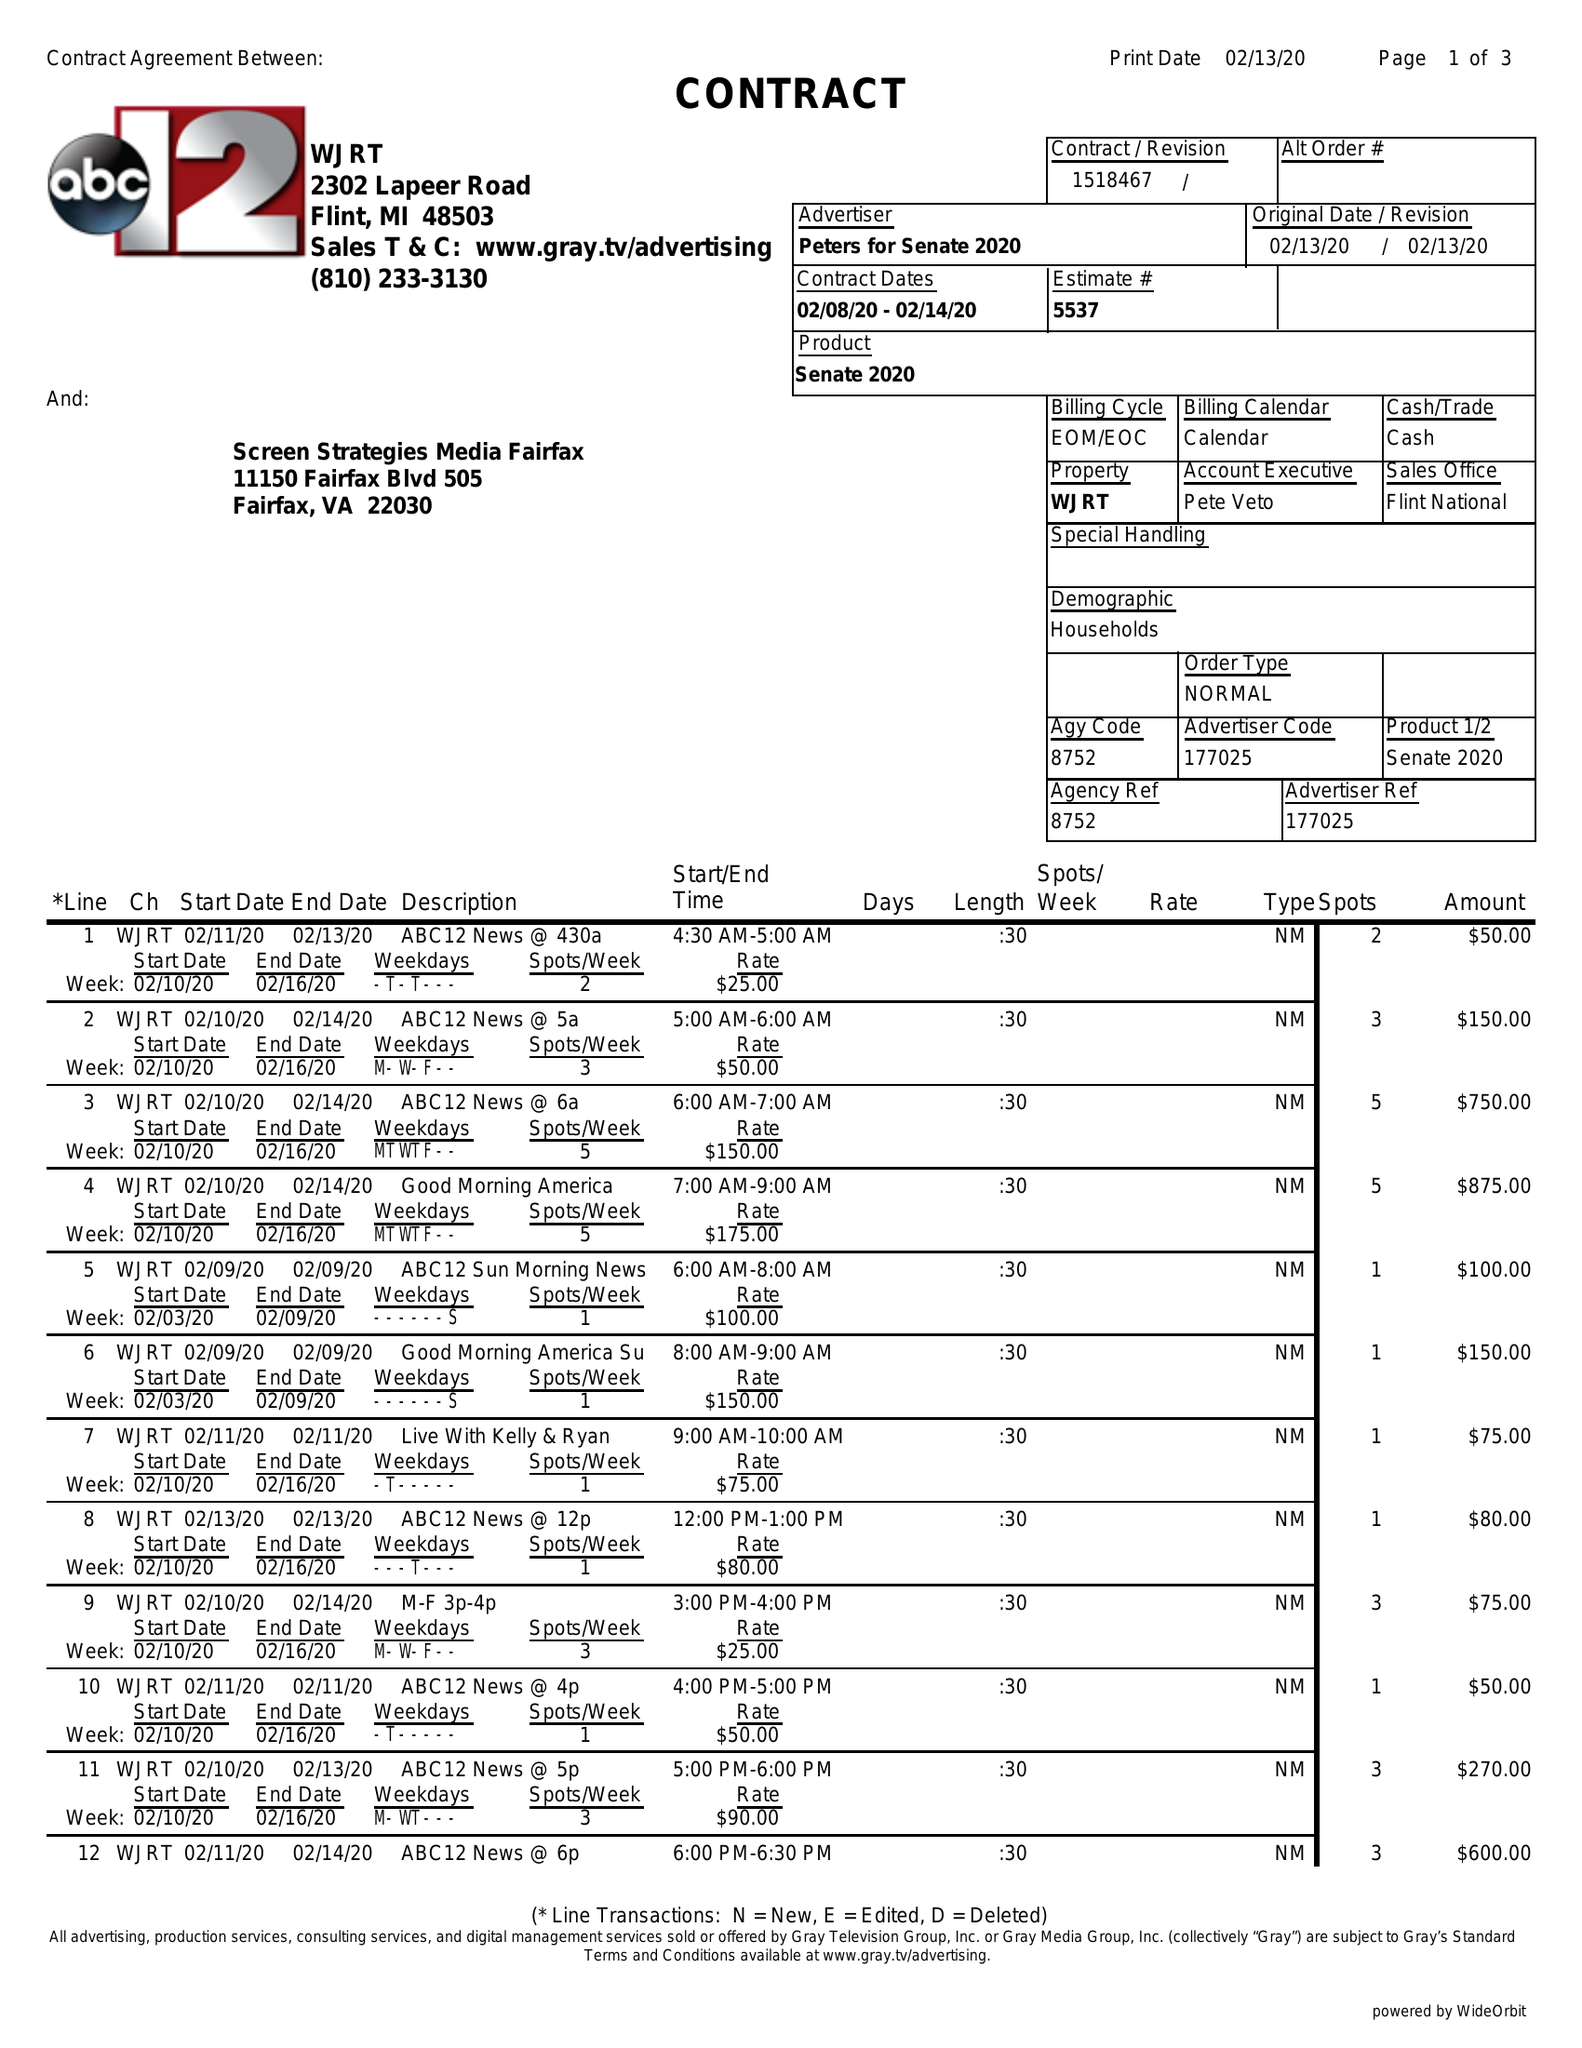What is the value for the flight_to?
Answer the question using a single word or phrase. 02/14/20 